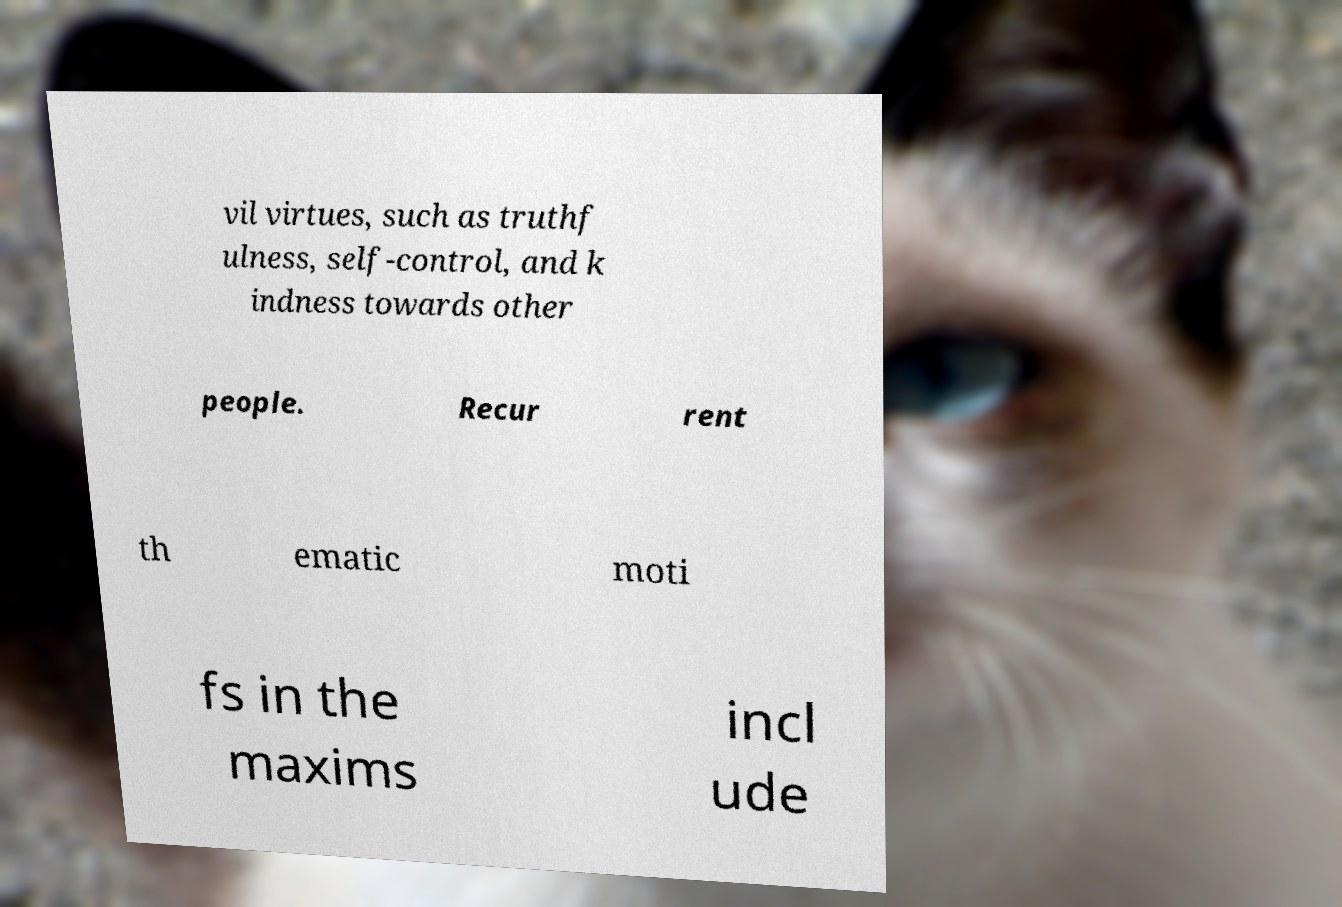Please read and relay the text visible in this image. What does it say? vil virtues, such as truthf ulness, self-control, and k indness towards other people. Recur rent th ematic moti fs in the maxims incl ude 